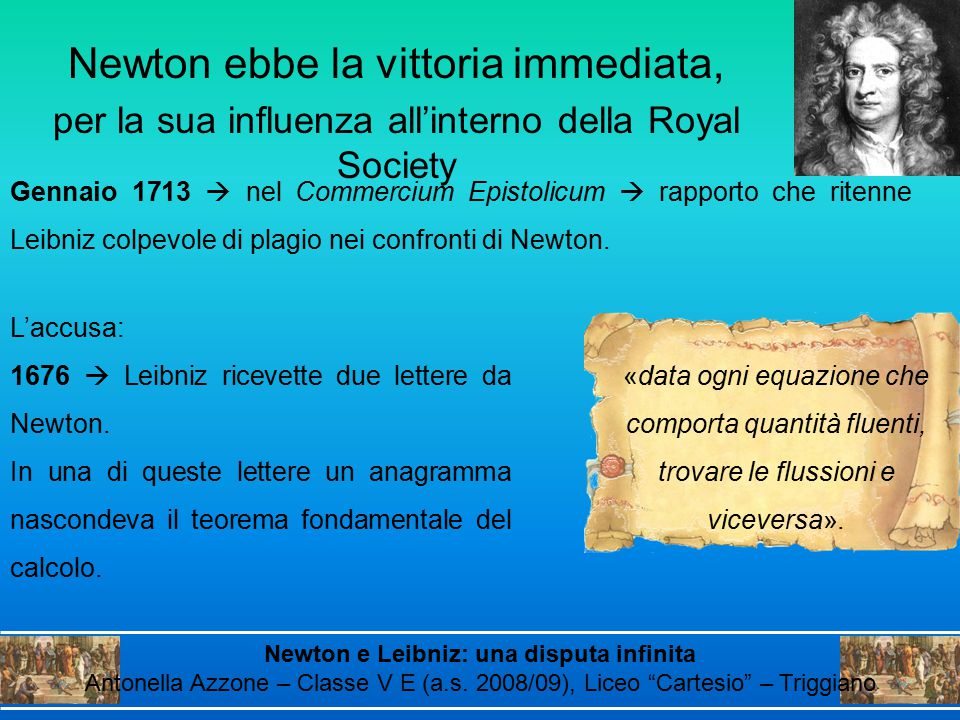If this historical event were adapted into a video game, what would be an exciting level involving the anagram? In a video game adaptation of the Newton-Leibniz dispute, an exciting level involving the anagram would be set within a meticulously recreated 17th-century European city. The player, assuming the role of either Newton or Leibniz, would embark on a quest to deliver or decipher the anagram. This level would include navigating through bustling marketplaces, evading espionage attempts by rival scholars, and solving intricate puzzles to uncover the hidden message in the letter. Along the way, players would gather clues from various historical figures and artifacts, immersing them in the rich context of the era. The climax of the level would be a high-stakes debate within the grand halls of the Royal Society, where the player must present their findings and defend their conclusions against a skeptical audience. Success in this level would require a blend of intellectual prowess, strategic thinking, and quick reflexes, making for an exhilarating and educational gaming experience. 